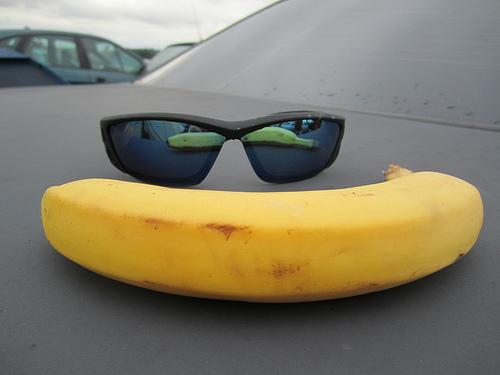Discuss the surface that the sunglasses and banana are placed on. The sunglasses and banana are sitting on the black hood of a car. What can you say about the weather in the image and the time of the day? It seems to be a cloudy day during daytime. Provide information about the sunglasses, including their color and the appearance of the lenses. The sunglasses are black with blue-tinted reflective lenses. Which object has a reflection of another object in it and what is the reflected object? The sunglasses have a reflection of a banana in their lenses. Choose one of the vehicles present in the background and describe its color and type. There is a blue sedan in the background. What kind of scene is depicted in the background? There is a car with trees and a cloudy sky in the background. Where are the sunglasses and banana in relation to the car? The sunglasses and banana are on the car hood. Describe the condition of the car window and the detail on it. The car window is dirty and has white horizontal lines and small dots at the bottom. Identify the two main objects in the image and describe their colors. There is a black pair of sunglasses and a yellow banana in the image. What imperfections can be spotted on the banana? There are brown spots on the banana. 